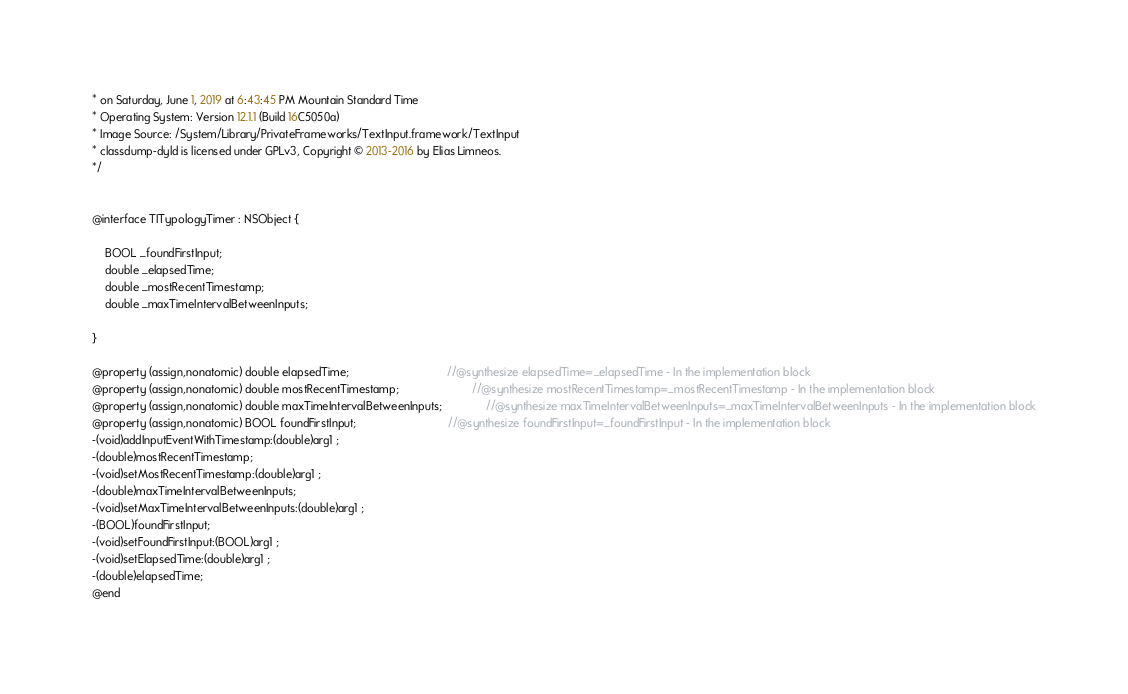<code> <loc_0><loc_0><loc_500><loc_500><_C_>* on Saturday, June 1, 2019 at 6:43:45 PM Mountain Standard Time
* Operating System: Version 12.1.1 (Build 16C5050a)
* Image Source: /System/Library/PrivateFrameworks/TextInput.framework/TextInput
* classdump-dyld is licensed under GPLv3, Copyright © 2013-2016 by Elias Limneos.
*/


@interface TITypologyTimer : NSObject {

	BOOL _foundFirstInput;
	double _elapsedTime;
	double _mostRecentTimestamp;
	double _maxTimeIntervalBetweenInputs;

}

@property (assign,nonatomic) double elapsedTime;                               //@synthesize elapsedTime=_elapsedTime - In the implementation block
@property (assign,nonatomic) double mostRecentTimestamp;                       //@synthesize mostRecentTimestamp=_mostRecentTimestamp - In the implementation block
@property (assign,nonatomic) double maxTimeIntervalBetweenInputs;              //@synthesize maxTimeIntervalBetweenInputs=_maxTimeIntervalBetweenInputs - In the implementation block
@property (assign,nonatomic) BOOL foundFirstInput;                             //@synthesize foundFirstInput=_foundFirstInput - In the implementation block
-(void)addInputEventWithTimestamp:(double)arg1 ;
-(double)mostRecentTimestamp;
-(void)setMostRecentTimestamp:(double)arg1 ;
-(double)maxTimeIntervalBetweenInputs;
-(void)setMaxTimeIntervalBetweenInputs:(double)arg1 ;
-(BOOL)foundFirstInput;
-(void)setFoundFirstInput:(BOOL)arg1 ;
-(void)setElapsedTime:(double)arg1 ;
-(double)elapsedTime;
@end

</code> 